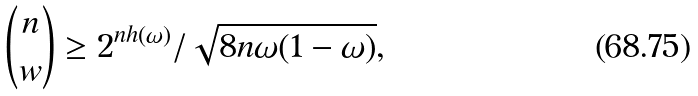Convert formula to latex. <formula><loc_0><loc_0><loc_500><loc_500>\binom { n } { w } \geq 2 ^ { n h ( \omega ) } / \sqrt { 8 n \omega ( 1 - \omega ) } ,</formula> 